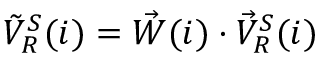Convert formula to latex. <formula><loc_0><loc_0><loc_500><loc_500>\begin{array} { r } { \tilde { V } _ { R } ^ { S } ( i ) = \vec { W } ( i ) \cdot \vec { V } _ { R } ^ { S } ( i ) } \end{array}</formula> 